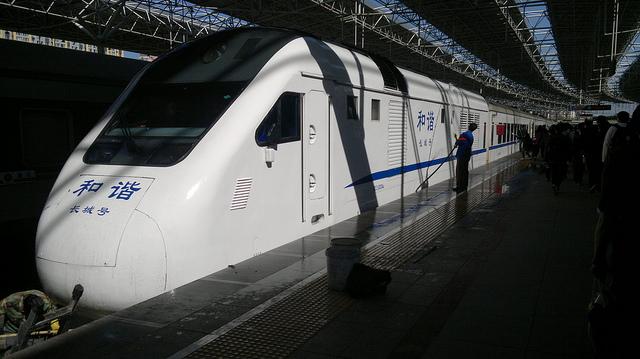What is this vehicle called?
Write a very short answer. Train. What language is on the front of this?
Give a very brief answer. Chinese. How many red stripes are painted on the train?
Write a very short answer. 0. Can this go faster than 40 miles per hour?
Give a very brief answer. Yes. What type of aircraft is pictured?
Answer briefly. None. Is someone cleaning the train?
Keep it brief. Yes. 